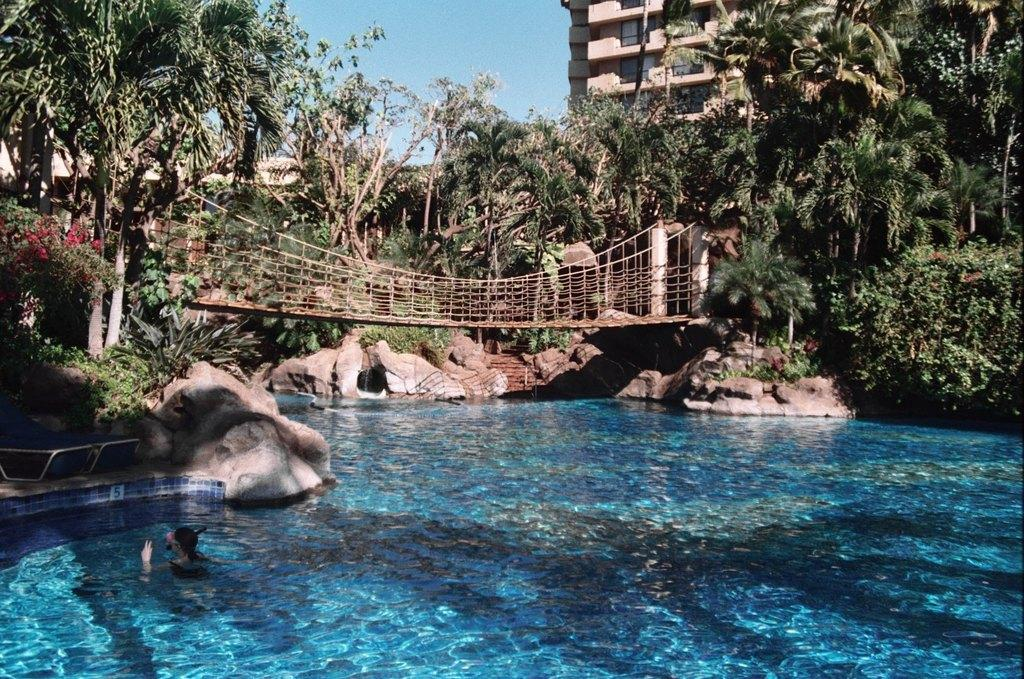What is the main subject of the image? There is a person in the water in the center of the image. What can be seen in the background of the image? The sky, at least one building, windows, trees, flowers, stones, and a few other objects are visible in the background. Can you describe the natural elements in the background? Trees and flowers are the natural elements present in the background. How many boys are skating on the care in the image? There are no boys or cars present in the image; it features a person in the water and various background elements. 